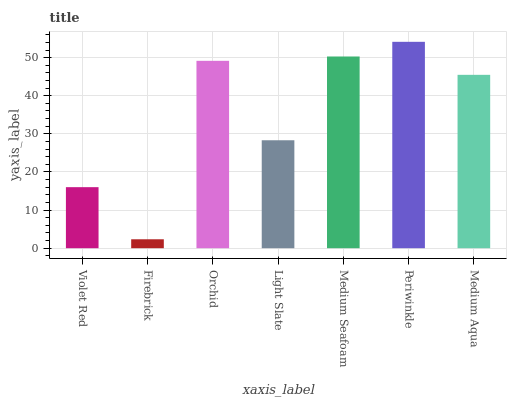Is Firebrick the minimum?
Answer yes or no. Yes. Is Periwinkle the maximum?
Answer yes or no. Yes. Is Orchid the minimum?
Answer yes or no. No. Is Orchid the maximum?
Answer yes or no. No. Is Orchid greater than Firebrick?
Answer yes or no. Yes. Is Firebrick less than Orchid?
Answer yes or no. Yes. Is Firebrick greater than Orchid?
Answer yes or no. No. Is Orchid less than Firebrick?
Answer yes or no. No. Is Medium Aqua the high median?
Answer yes or no. Yes. Is Medium Aqua the low median?
Answer yes or no. Yes. Is Medium Seafoam the high median?
Answer yes or no. No. Is Medium Seafoam the low median?
Answer yes or no. No. 